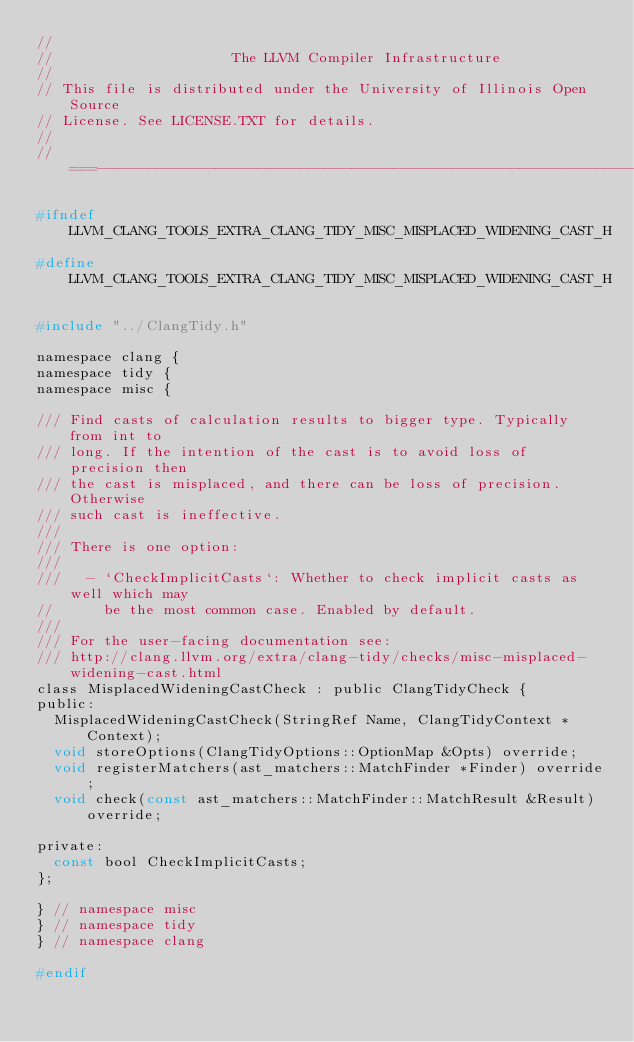Convert code to text. <code><loc_0><loc_0><loc_500><loc_500><_C_>//
//                     The LLVM Compiler Infrastructure
//
// This file is distributed under the University of Illinois Open Source
// License. See LICENSE.TXT for details.
//
//===----------------------------------------------------------------------===//

#ifndef LLVM_CLANG_TOOLS_EXTRA_CLANG_TIDY_MISC_MISPLACED_WIDENING_CAST_H
#define LLVM_CLANG_TOOLS_EXTRA_CLANG_TIDY_MISC_MISPLACED_WIDENING_CAST_H

#include "../ClangTidy.h"

namespace clang {
namespace tidy {
namespace misc {

/// Find casts of calculation results to bigger type. Typically from int to
/// long. If the intention of the cast is to avoid loss of precision then
/// the cast is misplaced, and there can be loss of precision. Otherwise
/// such cast is ineffective.
///
/// There is one option:
///
///   - `CheckImplicitCasts`: Whether to check implicit casts as well which may
//      be the most common case. Enabled by default.
///
/// For the user-facing documentation see:
/// http://clang.llvm.org/extra/clang-tidy/checks/misc-misplaced-widening-cast.html
class MisplacedWideningCastCheck : public ClangTidyCheck {
public:
  MisplacedWideningCastCheck(StringRef Name, ClangTidyContext *Context);
  void storeOptions(ClangTidyOptions::OptionMap &Opts) override;
  void registerMatchers(ast_matchers::MatchFinder *Finder) override;
  void check(const ast_matchers::MatchFinder::MatchResult &Result) override;

private:
  const bool CheckImplicitCasts;
};

} // namespace misc
} // namespace tidy
} // namespace clang

#endif
</code> 